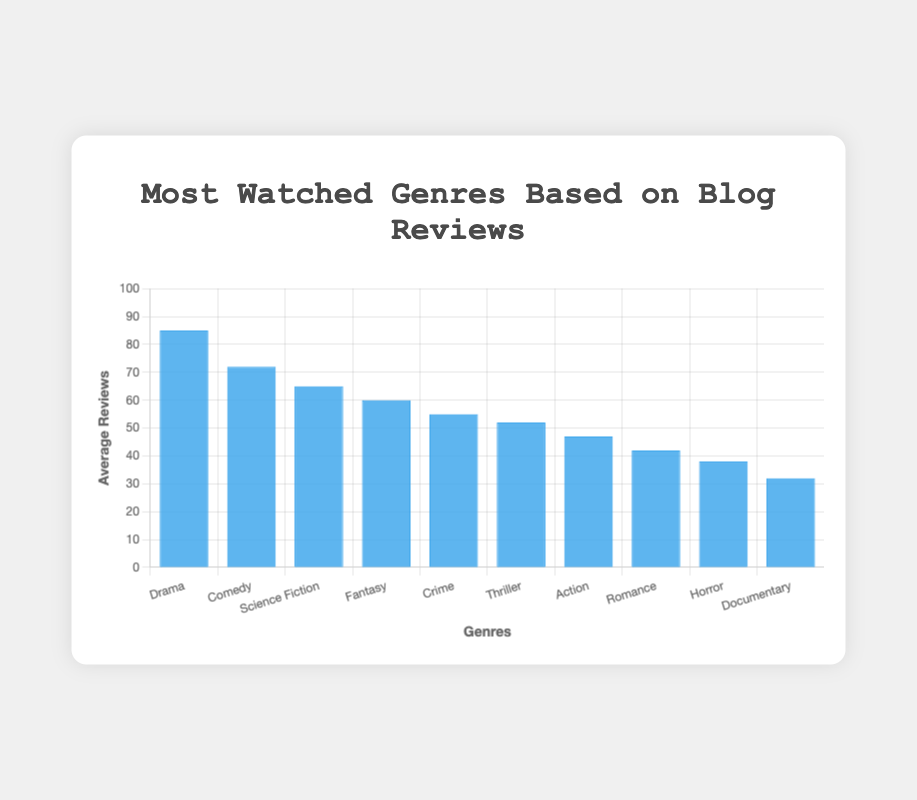Which genre has the highest average number of reviews? By looking at the bar heights for each genre, the blue bar for Drama is the tallest. This indicates that Drama has the highest average number of reviews.
Answer: Drama How many fewer average reviews does Comedy have compared to Drama? The average reviews for Drama are 85, and for Comedy, it's 72. Subtract Comedy's average reviews from Drama's average reviews: 85 - 72 = 13.
Answer: 13 What is the total average number of reviews for Science Fiction, Fantasy, and Crime? Add the average reviews for Science Fiction (65), Fantasy (60), and Crime (55): 65 + 60 + 55 = 180.
Answer: 180 Which genre has the fewest average reviews? The blue bar for Documentary is the shortest among all the bars, indicating it has the fewest average reviews.
Answer: Documentary Are there more average reviews for Action or Romance? By comparing the heights of the blue bars for Action and Romance, the bar for Action (47) is taller than the bar for Romance (42).
Answer: Action How many genres have an average review count of 50 or more? Count the genres where the blue bars represent 50 or more average reviews: Drama, Comedy, Science Fiction, Fantasy, Crime, and Thriller. This gives a total of 6 genres.
Answer: 6 What is the difference in average reviews between the genre with the highest reviews and the genre with the lowest reviews? The genre with the highest average reviews is Drama (85), and the genre with the lowest average reviews is Documentary (32). The difference is 85 - 32 = 53.
Answer: 53 How much does the average review count for Fantasy differ from that of Thriller and Horror combined? The average reviews for Fantasy are 60. The combined average reviews for Thriller (52) and Horror (38) are 52 + 38 = 90. The difference is 90 - 60 = 30.
Answer: 30 What is the average number of reviews for Drama, Comedy, and Documentary combined? Sum the average reviews for Drama (85), Comedy (72), and Documentary (32): 85 + 72 + 32 = 189. Then divide by 3 to find the average: 189 / 3 = 63.
Answer: 63 